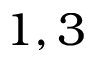<formula> <loc_0><loc_0><loc_500><loc_500>1 , 3</formula> 